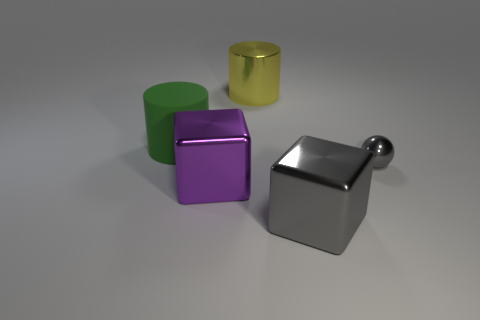Is there any other thing that is made of the same material as the green thing?
Ensure brevity in your answer.  No. Is there anything else that has the same size as the gray sphere?
Give a very brief answer. No. How many large purple cubes are to the right of the large metallic thing that is behind the purple metallic cube?
Offer a terse response. 0. Is the color of the block that is on the right side of the large metal cylinder the same as the ball that is behind the purple thing?
Keep it short and to the point. Yes. There is a metallic thing that is both left of the gray shiny cube and behind the large purple block; what shape is it?
Give a very brief answer. Cylinder. Is there another large thing of the same shape as the green matte object?
Provide a succinct answer. Yes. The gray object that is the same size as the yellow object is what shape?
Offer a very short reply. Cube. What is the green cylinder made of?
Provide a succinct answer. Rubber. What is the size of the cube that is in front of the block to the left of the cylinder that is on the right side of the large purple object?
Ensure brevity in your answer.  Large. What number of metal things are gray cylinders or tiny gray things?
Ensure brevity in your answer.  1. 